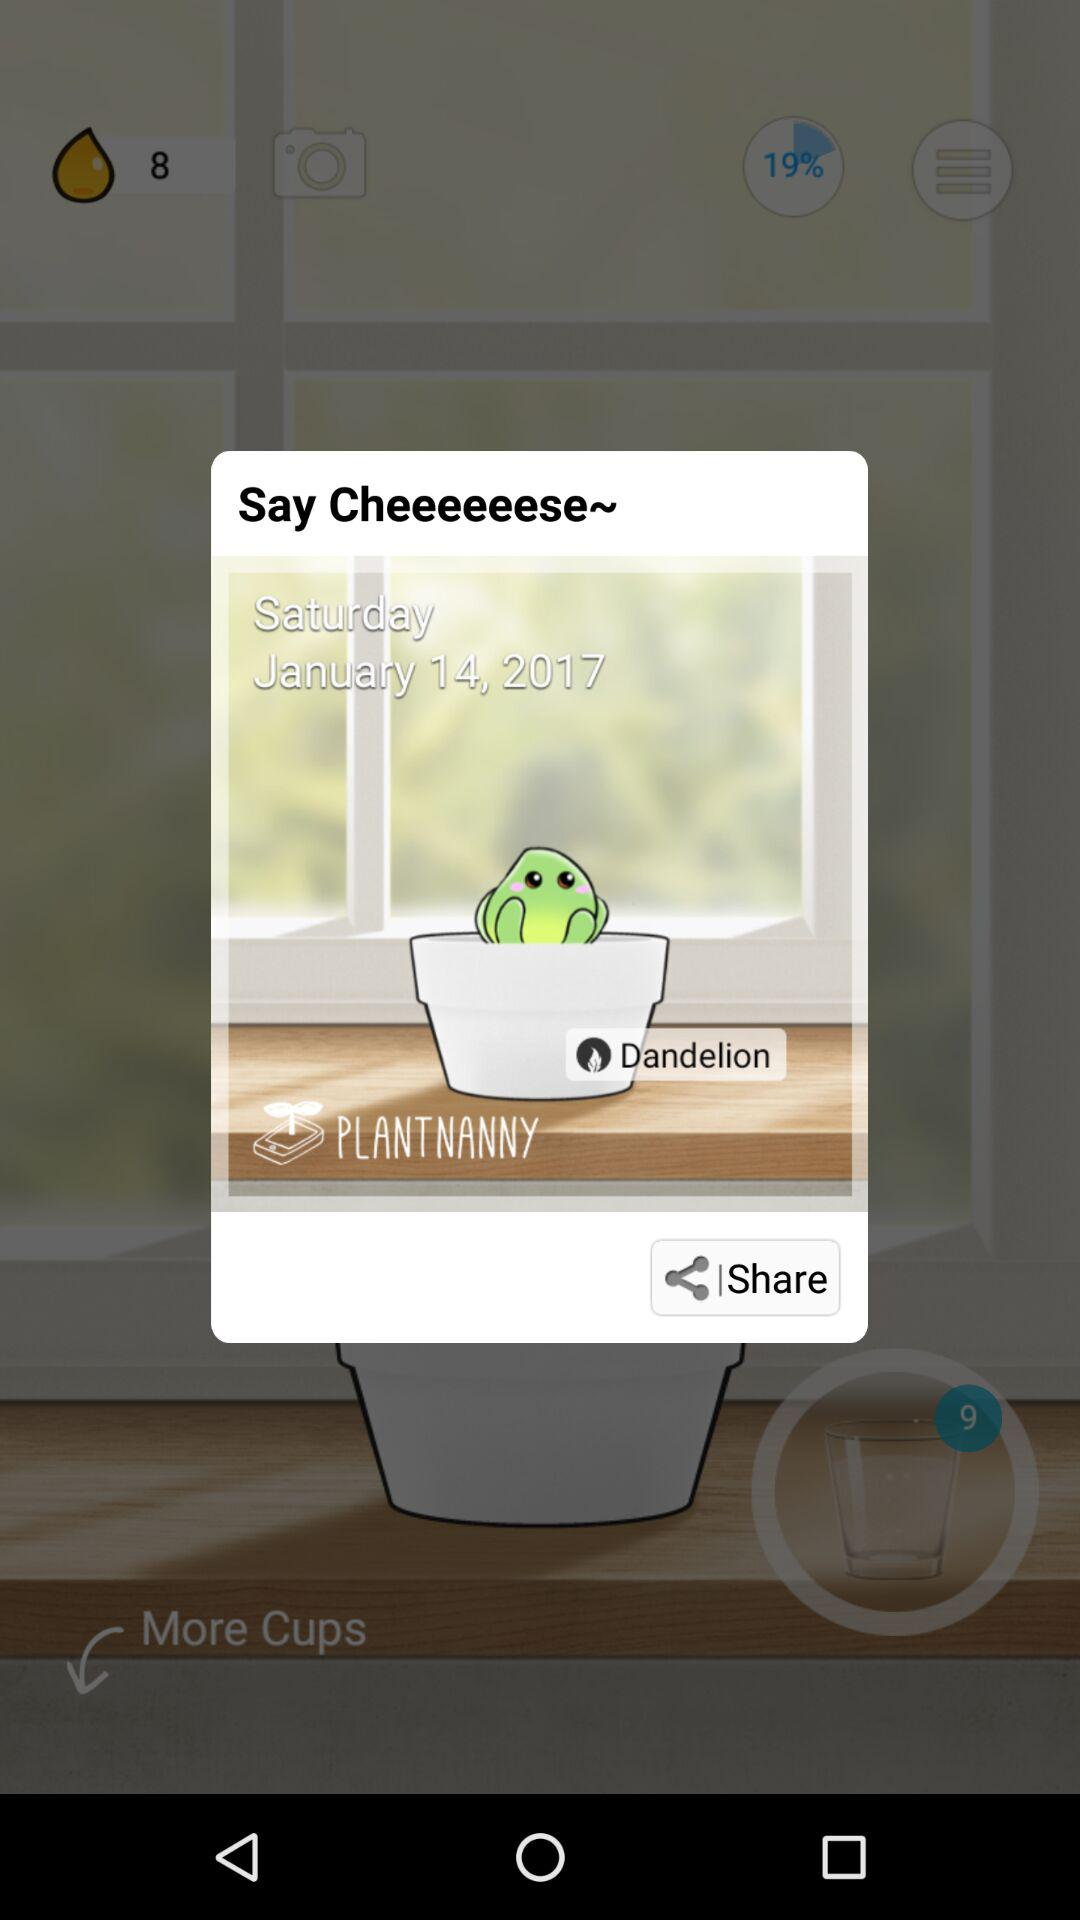How many photos of the plant have been taken?
When the provided information is insufficient, respond with <no answer>. <no answer> 